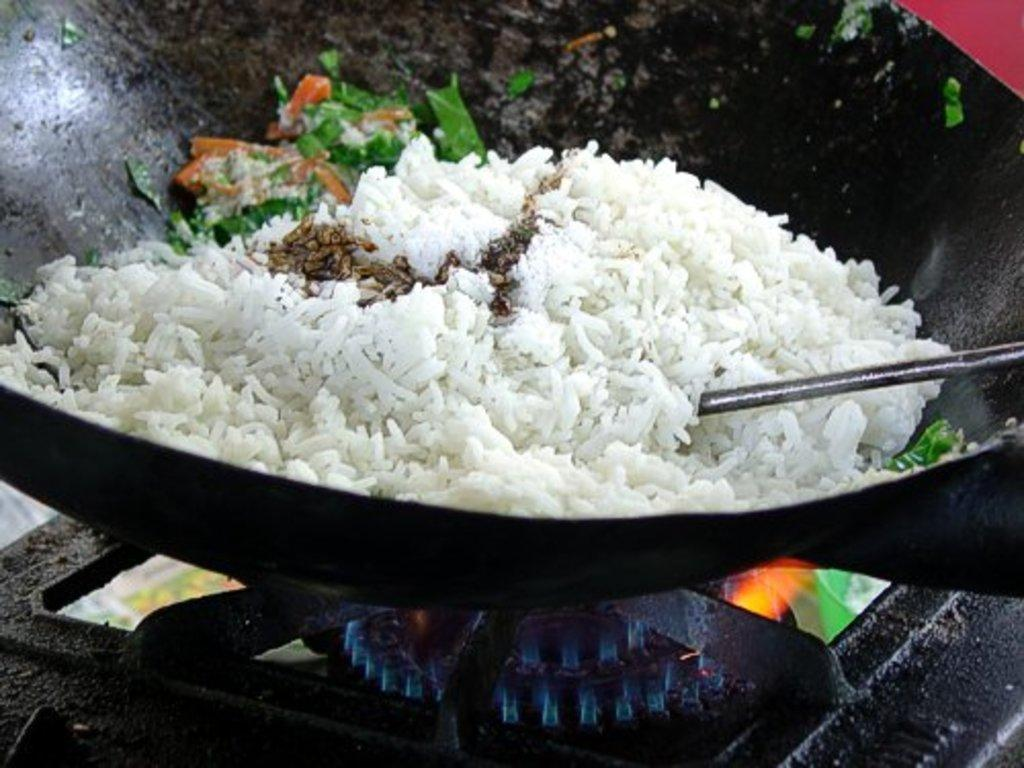What is the color of the vessel in the image? The vessel is black-colored in the image. Where is the vessel located in the image? The vessel is placed on a gas stove in the image. What is being cooked in the vessel? Rice is cooking in the vessel. What utensil is present in the vessel? There is a spoon in the vessel. What is the rate of the vessel's voyage in the image? There is no voyage or vessel movement in the image, as the vessel is stationary on a gas stove. Can you tell me how many forks are present in the image? There is no fork present in the image; only a spoon is visible in the vessel. 